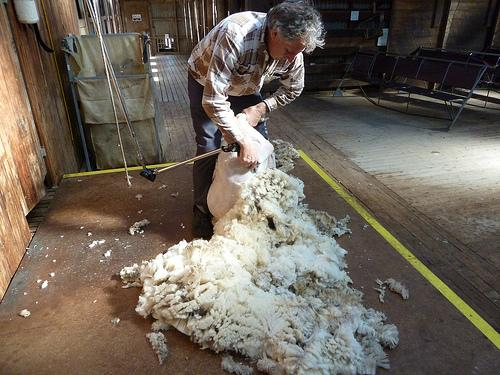What type of clothing is the man wearing in the image? The man is wearing a plaid shirt and dark blue jeans. Name one type of seating arrangement mentioned in the image captions. Rows of dark metal seats. What is the purpose of the electrical device being used in the image? The electrical device is used for shaving the wool off a sheep. What type of fabric receptacle is mentioned in the captions? A tan cloth receptacle with metal supports. What color is the line painted on the floor in the image? Yellow. Provide a brief description of the image focusing on the people and animals. An elderly man with grey hair is shearing a sheep while wearing a plaid shirt and dark blue jeans. Identify the primary action taking place in the image. A man with grey hair is shearing a sheep using an electrical shaver. Who are the two primary subjects in the image? The man with grey hair and the sheep being sheared. Enumerate the objects grouped in front of the man with grey hair. A yellow line, a white bag holding wool, and sheared white wool on the ground. 